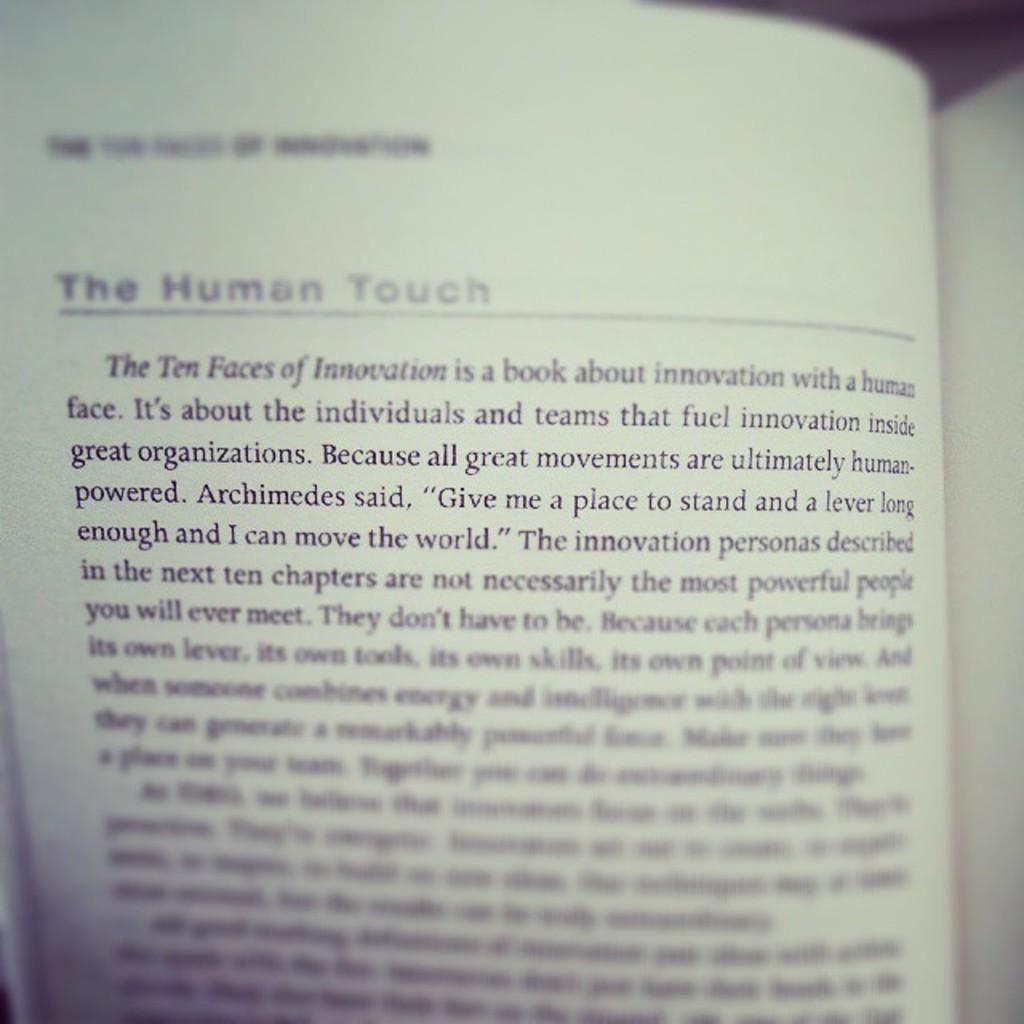<image>
Provide a brief description of the given image. A book that is open to a page with the heading The Human Touch. 